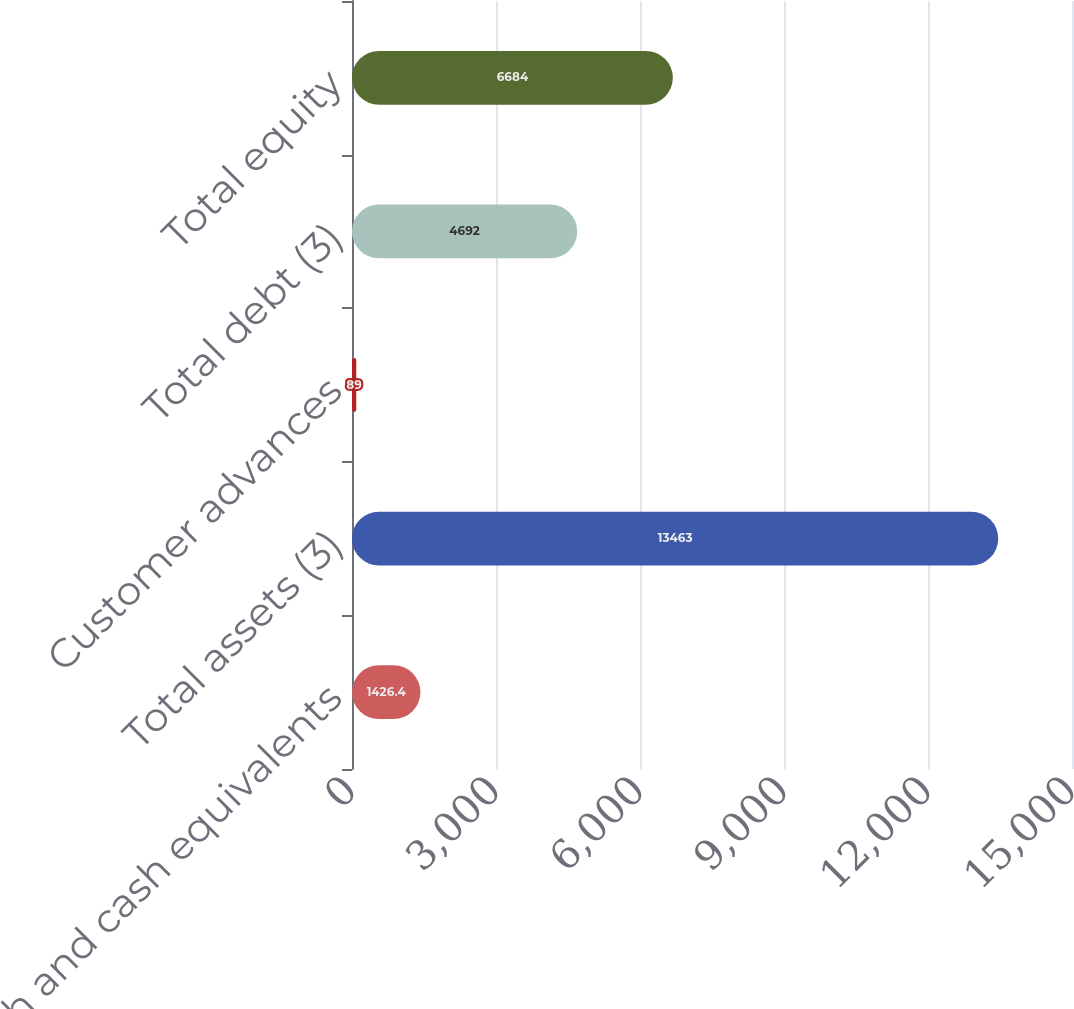<chart> <loc_0><loc_0><loc_500><loc_500><bar_chart><fcel>Cash and cash equivalents<fcel>Total assets (3)<fcel>Customer advances<fcel>Total debt (3)<fcel>Total equity<nl><fcel>1426.4<fcel>13463<fcel>89<fcel>4692<fcel>6684<nl></chart> 